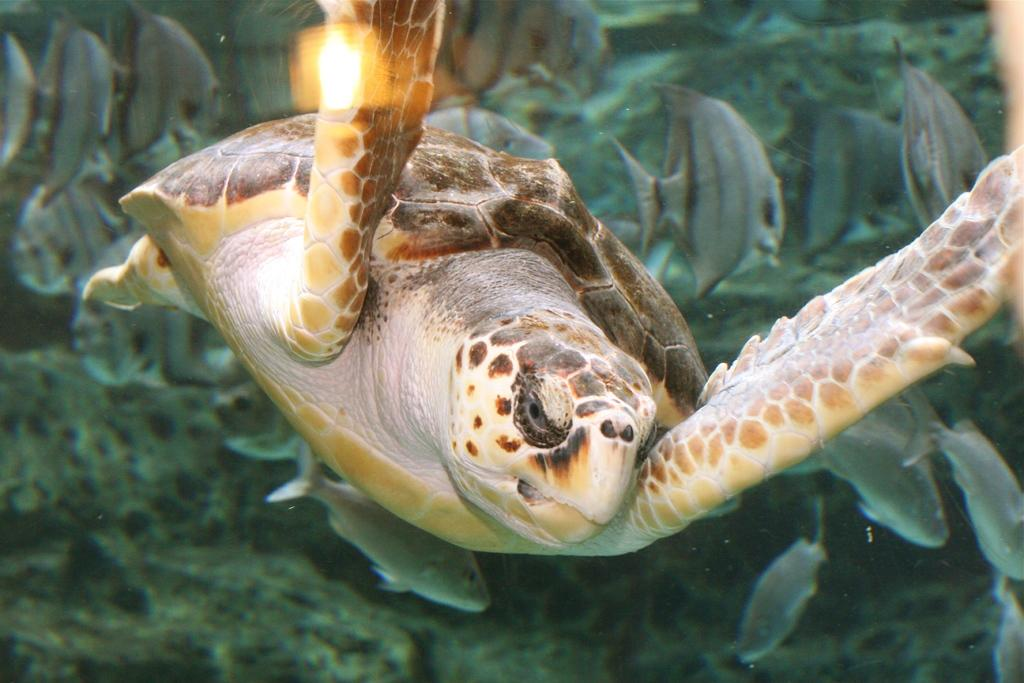What animal is the main subject of the image? There is a turtle in the image. Can you describe the turtle's color? The turtle has a white, cream, and brown color. What else can be seen in the image besides the turtle? There are fishes in the background of the image. What type of guitar is the turtle playing in the image? There is no guitar present in the image; it features a turtle and fishes. Can you tell me how many donkeys are visible in the image? There are no donkeys present in the image; it only features a turtle and fishes. 